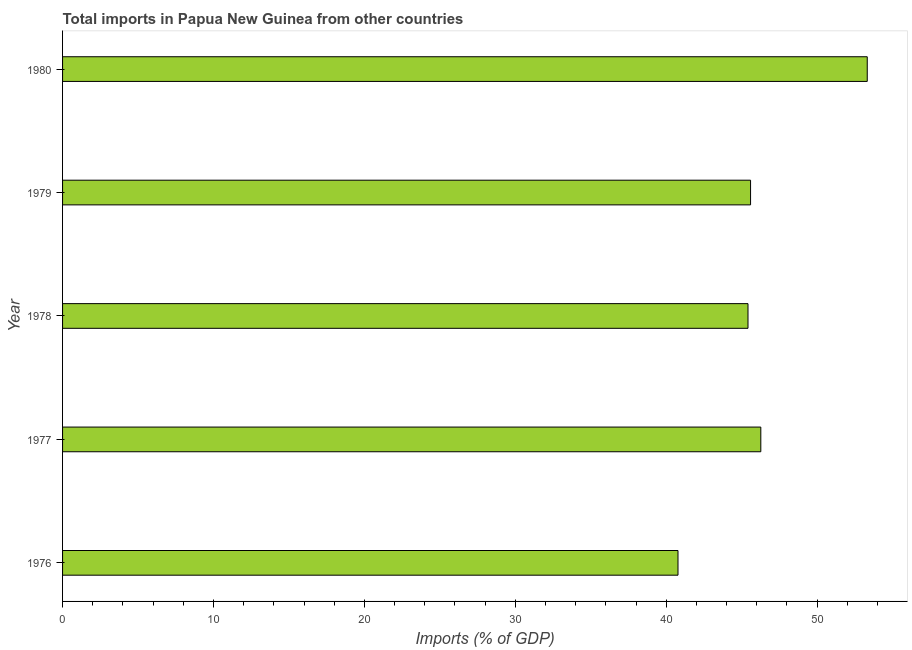Does the graph contain grids?
Provide a succinct answer. No. What is the title of the graph?
Your answer should be very brief. Total imports in Papua New Guinea from other countries. What is the label or title of the X-axis?
Offer a very short reply. Imports (% of GDP). What is the label or title of the Y-axis?
Keep it short and to the point. Year. What is the total imports in 1979?
Make the answer very short. 45.59. Across all years, what is the maximum total imports?
Provide a succinct answer. 53.32. Across all years, what is the minimum total imports?
Make the answer very short. 40.78. In which year was the total imports minimum?
Give a very brief answer. 1976. What is the sum of the total imports?
Offer a terse response. 231.38. What is the difference between the total imports in 1977 and 1978?
Make the answer very short. 0.85. What is the average total imports per year?
Ensure brevity in your answer.  46.28. What is the median total imports?
Your response must be concise. 45.59. Do a majority of the years between 1976 and 1978 (inclusive) have total imports greater than 46 %?
Your answer should be compact. No. What is the ratio of the total imports in 1976 to that in 1980?
Offer a very short reply. 0.77. What is the difference between the highest and the second highest total imports?
Make the answer very short. 7.05. Is the sum of the total imports in 1976 and 1978 greater than the maximum total imports across all years?
Make the answer very short. Yes. What is the difference between the highest and the lowest total imports?
Give a very brief answer. 12.54. In how many years, is the total imports greater than the average total imports taken over all years?
Provide a succinct answer. 1. Are the values on the major ticks of X-axis written in scientific E-notation?
Ensure brevity in your answer.  No. What is the Imports (% of GDP) of 1976?
Provide a succinct answer. 40.78. What is the Imports (% of GDP) of 1977?
Keep it short and to the point. 46.27. What is the Imports (% of GDP) in 1978?
Offer a terse response. 45.42. What is the Imports (% of GDP) of 1979?
Offer a terse response. 45.59. What is the Imports (% of GDP) in 1980?
Provide a short and direct response. 53.32. What is the difference between the Imports (% of GDP) in 1976 and 1977?
Offer a terse response. -5.49. What is the difference between the Imports (% of GDP) in 1976 and 1978?
Your answer should be compact. -4.64. What is the difference between the Imports (% of GDP) in 1976 and 1979?
Ensure brevity in your answer.  -4.81. What is the difference between the Imports (% of GDP) in 1976 and 1980?
Give a very brief answer. -12.54. What is the difference between the Imports (% of GDP) in 1977 and 1978?
Make the answer very short. 0.85. What is the difference between the Imports (% of GDP) in 1977 and 1979?
Offer a very short reply. 0.68. What is the difference between the Imports (% of GDP) in 1977 and 1980?
Provide a short and direct response. -7.05. What is the difference between the Imports (% of GDP) in 1978 and 1979?
Offer a terse response. -0.17. What is the difference between the Imports (% of GDP) in 1978 and 1980?
Provide a short and direct response. -7.9. What is the difference between the Imports (% of GDP) in 1979 and 1980?
Give a very brief answer. -7.73. What is the ratio of the Imports (% of GDP) in 1976 to that in 1977?
Offer a terse response. 0.88. What is the ratio of the Imports (% of GDP) in 1976 to that in 1978?
Provide a succinct answer. 0.9. What is the ratio of the Imports (% of GDP) in 1976 to that in 1979?
Your answer should be compact. 0.9. What is the ratio of the Imports (% of GDP) in 1976 to that in 1980?
Make the answer very short. 0.77. What is the ratio of the Imports (% of GDP) in 1977 to that in 1980?
Your answer should be compact. 0.87. What is the ratio of the Imports (% of GDP) in 1978 to that in 1979?
Give a very brief answer. 1. What is the ratio of the Imports (% of GDP) in 1978 to that in 1980?
Provide a succinct answer. 0.85. What is the ratio of the Imports (% of GDP) in 1979 to that in 1980?
Your answer should be compact. 0.85. 